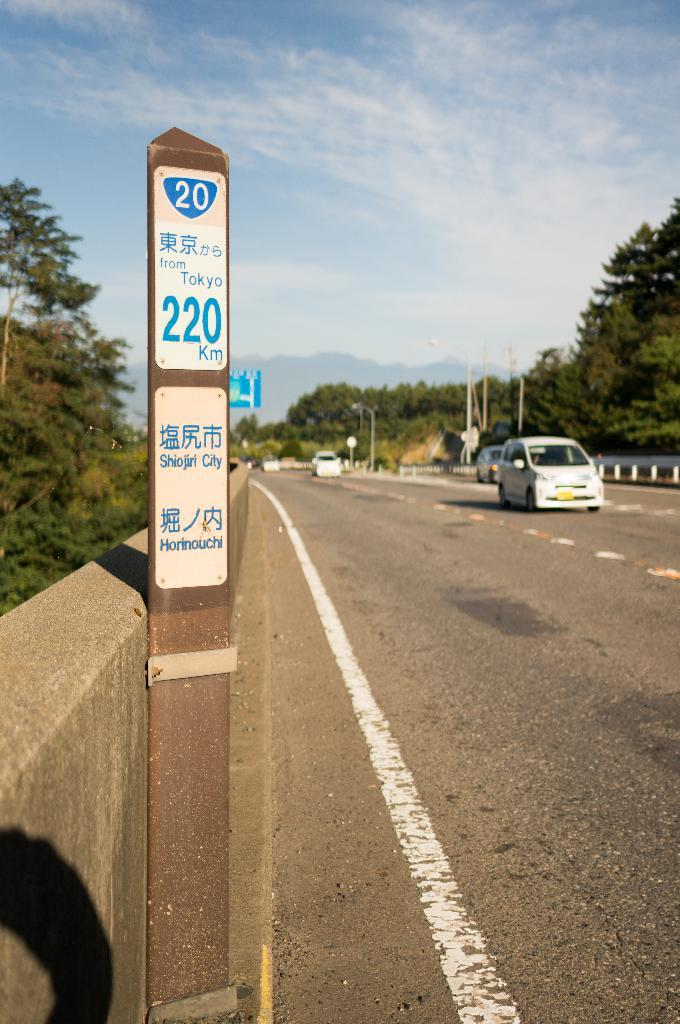Provide a one-sentence caption for the provided image. A street post shows a sign that says 200 km. 